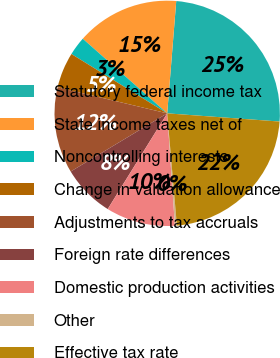Convert chart to OTSL. <chart><loc_0><loc_0><loc_500><loc_500><pie_chart><fcel>Statutory federal income tax<fcel>State income taxes net of<fcel>Noncontrolling interests<fcel>Change in valuation allowance<fcel>Adjustments to tax accruals<fcel>Foreign rate differences<fcel>Domestic production activities<fcel>Other<fcel>Effective tax rate<nl><fcel>24.88%<fcel>14.76%<fcel>2.69%<fcel>5.11%<fcel>12.35%<fcel>7.52%<fcel>9.94%<fcel>0.28%<fcel>22.47%<nl></chart> 